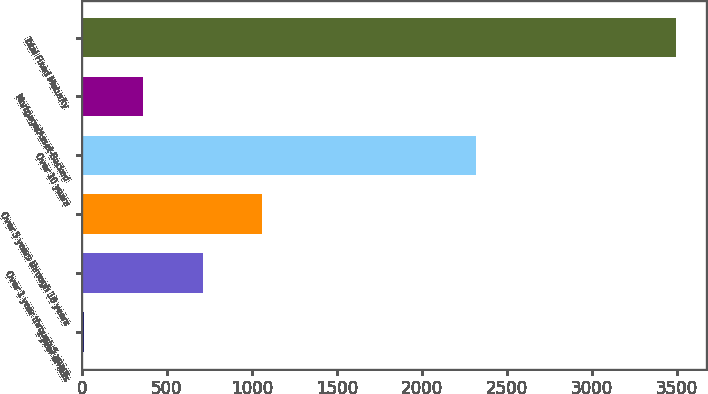Convert chart. <chart><loc_0><loc_0><loc_500><loc_500><bar_chart><fcel>1 year or less<fcel>Over 1 year through 5 years<fcel>Over 5 years through 10 years<fcel>Over 10 years<fcel>Mortgage/Asset-Backed<fcel>Total Fixed Maturity<nl><fcel>14.5<fcel>710.18<fcel>1058.02<fcel>2315.6<fcel>362.34<fcel>3492.9<nl></chart> 